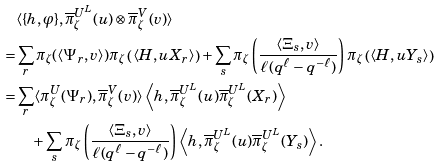<formula> <loc_0><loc_0><loc_500><loc_500>& \langle \{ h , \varphi \} , \overline { \pi } ^ { U ^ { L } } _ { \zeta } ( u ) \otimes \overline { \pi } ^ { V } _ { \zeta } ( v ) \rangle \\ = & \sum _ { r } \pi _ { \zeta } ( \langle \Psi _ { r } , v \rangle ) \pi _ { \zeta } \left ( \left \langle H , u X _ { r } \right \rangle \right ) + \sum _ { s } \pi _ { \zeta } \left ( \frac { \langle \Xi _ { s } , v \rangle } { \ell ( q ^ { \ell } - q ^ { - \ell } ) } \right ) \pi _ { \zeta } \left ( \left \langle H , u Y _ { s } \right \rangle \right ) \\ = & \sum _ { r } \langle \pi _ { \zeta } ^ { U } ( \Psi _ { r } ) , \overline { \pi } ^ { V } _ { \zeta } ( v ) \rangle \left \langle h , \overline { \pi } ^ { U ^ { L } } _ { \zeta } ( u ) \overline { \pi } ^ { U ^ { L } } _ { \zeta } ( X _ { r } ) \right \rangle \\ & \quad + \sum _ { s } \pi _ { \zeta } \left ( \frac { \langle \Xi _ { s } , v \rangle } { \ell ( q ^ { \ell } - q ^ { - \ell } ) } \right ) \left \langle h , \overline { \pi } ^ { U ^ { L } } _ { \zeta } ( u ) \overline { \pi } ^ { U ^ { L } } _ { \zeta } ( Y _ { s } ) \right \rangle .</formula> 